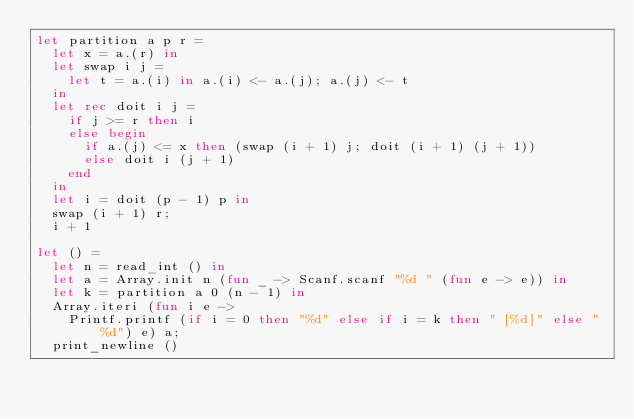Convert code to text. <code><loc_0><loc_0><loc_500><loc_500><_OCaml_>let partition a p r =
  let x = a.(r) in
  let swap i j =
    let t = a.(i) in a.(i) <- a.(j); a.(j) <- t
  in
  let rec doit i j =
    if j >= r then i
    else begin
      if a.(j) <= x then (swap (i + 1) j; doit (i + 1) (j + 1))
      else doit i (j + 1)
    end
  in
  let i = doit (p - 1) p in
  swap (i + 1) r;
  i + 1

let () =
  let n = read_int () in
  let a = Array.init n (fun _ -> Scanf.scanf "%d " (fun e -> e)) in
  let k = partition a 0 (n - 1) in
  Array.iteri (fun i e ->
    Printf.printf (if i = 0 then "%d" else if i = k then " [%d]" else " %d") e) a;
  print_newline ()</code> 